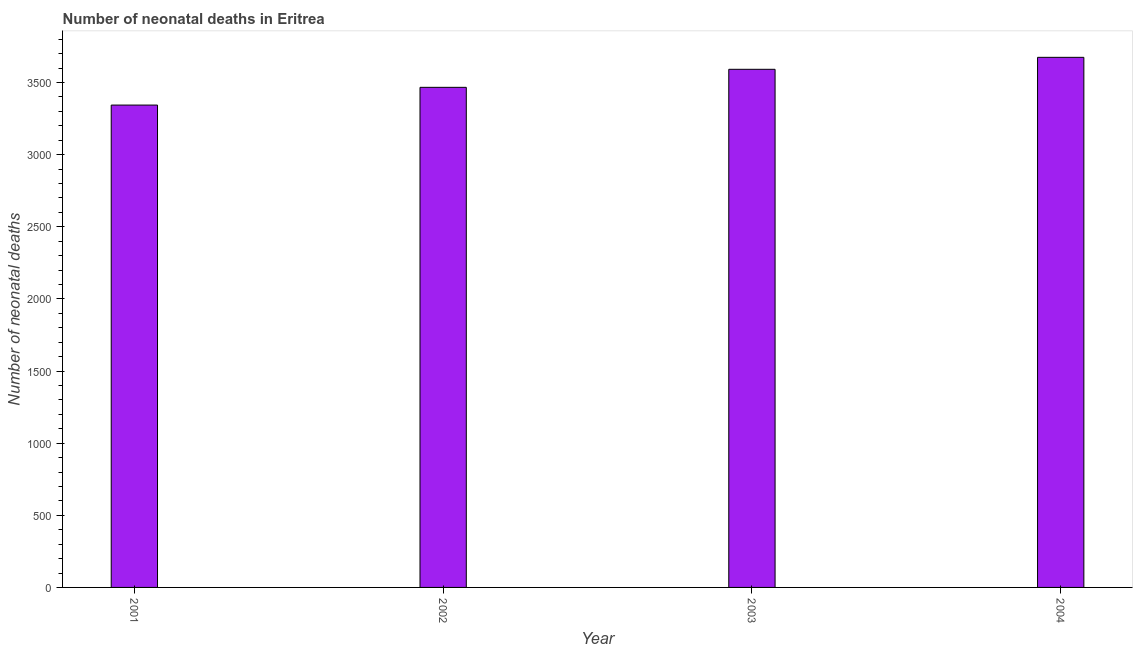Does the graph contain grids?
Provide a succinct answer. No. What is the title of the graph?
Give a very brief answer. Number of neonatal deaths in Eritrea. What is the label or title of the X-axis?
Provide a succinct answer. Year. What is the label or title of the Y-axis?
Keep it short and to the point. Number of neonatal deaths. What is the number of neonatal deaths in 2004?
Your response must be concise. 3675. Across all years, what is the maximum number of neonatal deaths?
Give a very brief answer. 3675. Across all years, what is the minimum number of neonatal deaths?
Your answer should be compact. 3344. In which year was the number of neonatal deaths maximum?
Offer a terse response. 2004. In which year was the number of neonatal deaths minimum?
Keep it short and to the point. 2001. What is the sum of the number of neonatal deaths?
Give a very brief answer. 1.41e+04. What is the difference between the number of neonatal deaths in 2001 and 2003?
Offer a very short reply. -248. What is the average number of neonatal deaths per year?
Your answer should be compact. 3519. What is the median number of neonatal deaths?
Offer a very short reply. 3529.5. In how many years, is the number of neonatal deaths greater than 1900 ?
Provide a succinct answer. 4. Do a majority of the years between 2003 and 2001 (inclusive) have number of neonatal deaths greater than 2400 ?
Offer a very short reply. Yes. What is the ratio of the number of neonatal deaths in 2001 to that in 2004?
Offer a very short reply. 0.91. Is the difference between the number of neonatal deaths in 2002 and 2004 greater than the difference between any two years?
Make the answer very short. No. What is the difference between the highest and the second highest number of neonatal deaths?
Your response must be concise. 83. What is the difference between the highest and the lowest number of neonatal deaths?
Offer a terse response. 331. Are all the bars in the graph horizontal?
Your response must be concise. No. How many years are there in the graph?
Give a very brief answer. 4. What is the Number of neonatal deaths in 2001?
Keep it short and to the point. 3344. What is the Number of neonatal deaths of 2002?
Make the answer very short. 3467. What is the Number of neonatal deaths of 2003?
Offer a terse response. 3592. What is the Number of neonatal deaths of 2004?
Your answer should be compact. 3675. What is the difference between the Number of neonatal deaths in 2001 and 2002?
Give a very brief answer. -123. What is the difference between the Number of neonatal deaths in 2001 and 2003?
Make the answer very short. -248. What is the difference between the Number of neonatal deaths in 2001 and 2004?
Offer a terse response. -331. What is the difference between the Number of neonatal deaths in 2002 and 2003?
Your answer should be compact. -125. What is the difference between the Number of neonatal deaths in 2002 and 2004?
Offer a very short reply. -208. What is the difference between the Number of neonatal deaths in 2003 and 2004?
Make the answer very short. -83. What is the ratio of the Number of neonatal deaths in 2001 to that in 2002?
Keep it short and to the point. 0.96. What is the ratio of the Number of neonatal deaths in 2001 to that in 2004?
Your answer should be compact. 0.91. What is the ratio of the Number of neonatal deaths in 2002 to that in 2004?
Offer a terse response. 0.94. 